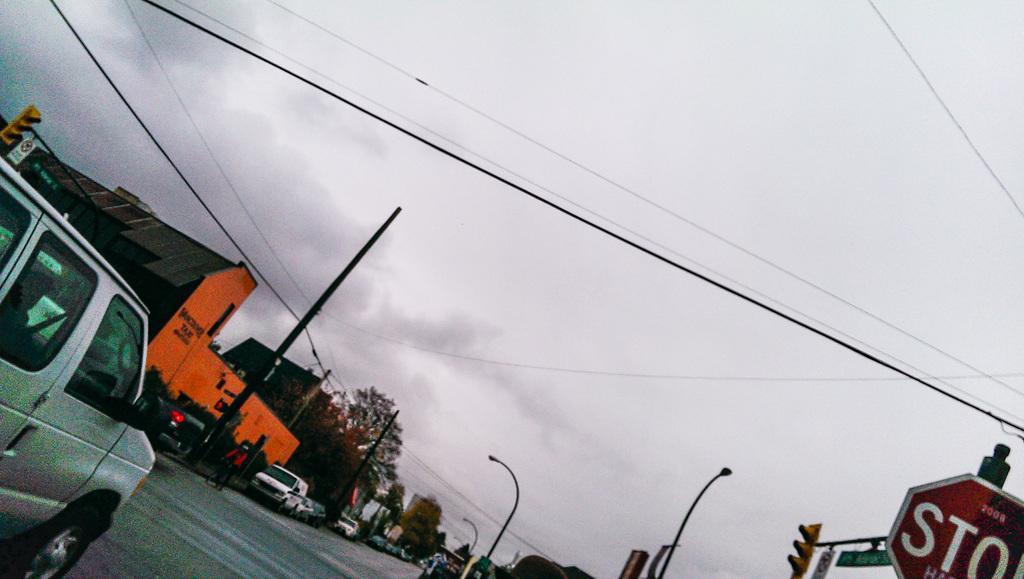Could you give a brief overview of what you see in this image? In this picture I can see there are some vehicles moving on the road and some vehicles are parked and I can find there are some poles, trees and buildings and the sky is clear. 